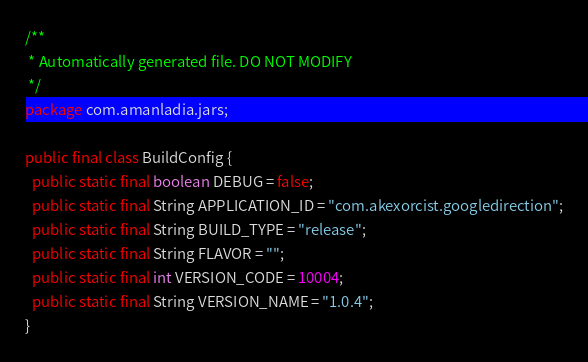<code> <loc_0><loc_0><loc_500><loc_500><_Java_>/**
 * Automatically generated file. DO NOT MODIFY
 */
package com.amanladia.jars;

public final class BuildConfig {
  public static final boolean DEBUG = false;
  public static final String APPLICATION_ID = "com.akexorcist.googledirection";
  public static final String BUILD_TYPE = "release";
  public static final String FLAVOR = "";
  public static final int VERSION_CODE = 10004;
  public static final String VERSION_NAME = "1.0.4";
}
</code> 